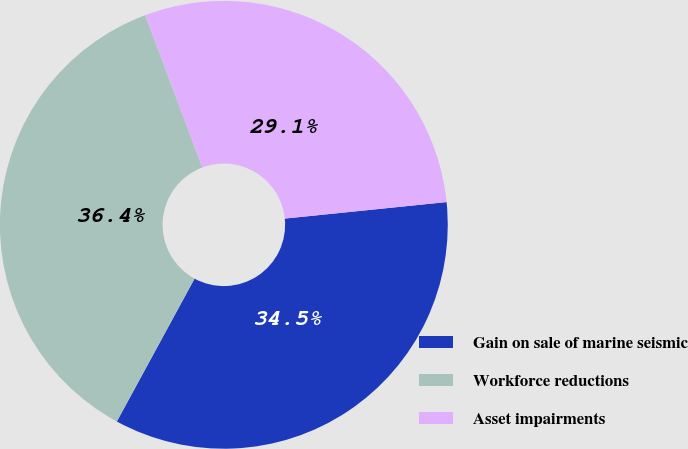Convert chart to OTSL. <chart><loc_0><loc_0><loc_500><loc_500><pie_chart><fcel>Gain on sale of marine seismic<fcel>Workforce reductions<fcel>Asset impairments<nl><fcel>34.55%<fcel>36.36%<fcel>29.09%<nl></chart> 